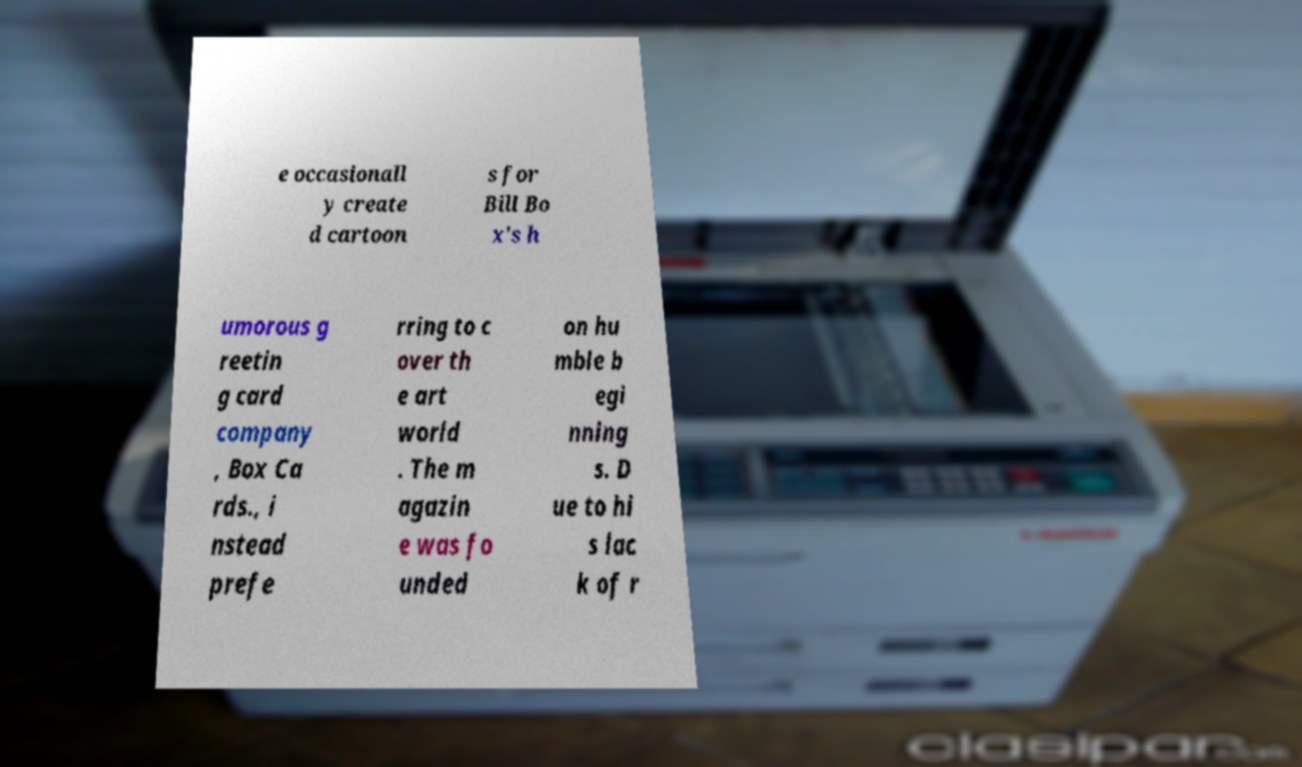Could you assist in decoding the text presented in this image and type it out clearly? e occasionall y create d cartoon s for Bill Bo x's h umorous g reetin g card company , Box Ca rds., i nstead prefe rring to c over th e art world . The m agazin e was fo unded on hu mble b egi nning s. D ue to hi s lac k of r 